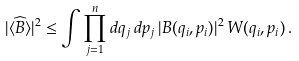<formula> <loc_0><loc_0><loc_500><loc_500>| \langle \widehat { B } \rangle | ^ { 2 } & \leq \int \prod _ { j = 1 } ^ { n } d q _ { j } \, d p _ { j } \, | B ( q _ { i } , p _ { i } ) | ^ { 2 } \, W ( q _ { i } , p _ { i } ) \, .</formula> 